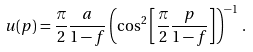Convert formula to latex. <formula><loc_0><loc_0><loc_500><loc_500>u ( p ) = \frac { \pi } { 2 } \frac { a } { 1 - f } \left ( \cos ^ { 2 } \left [ \frac { \pi } { 2 } \frac { p } { 1 - f } \right ] \right ) ^ { - 1 } \, .</formula> 